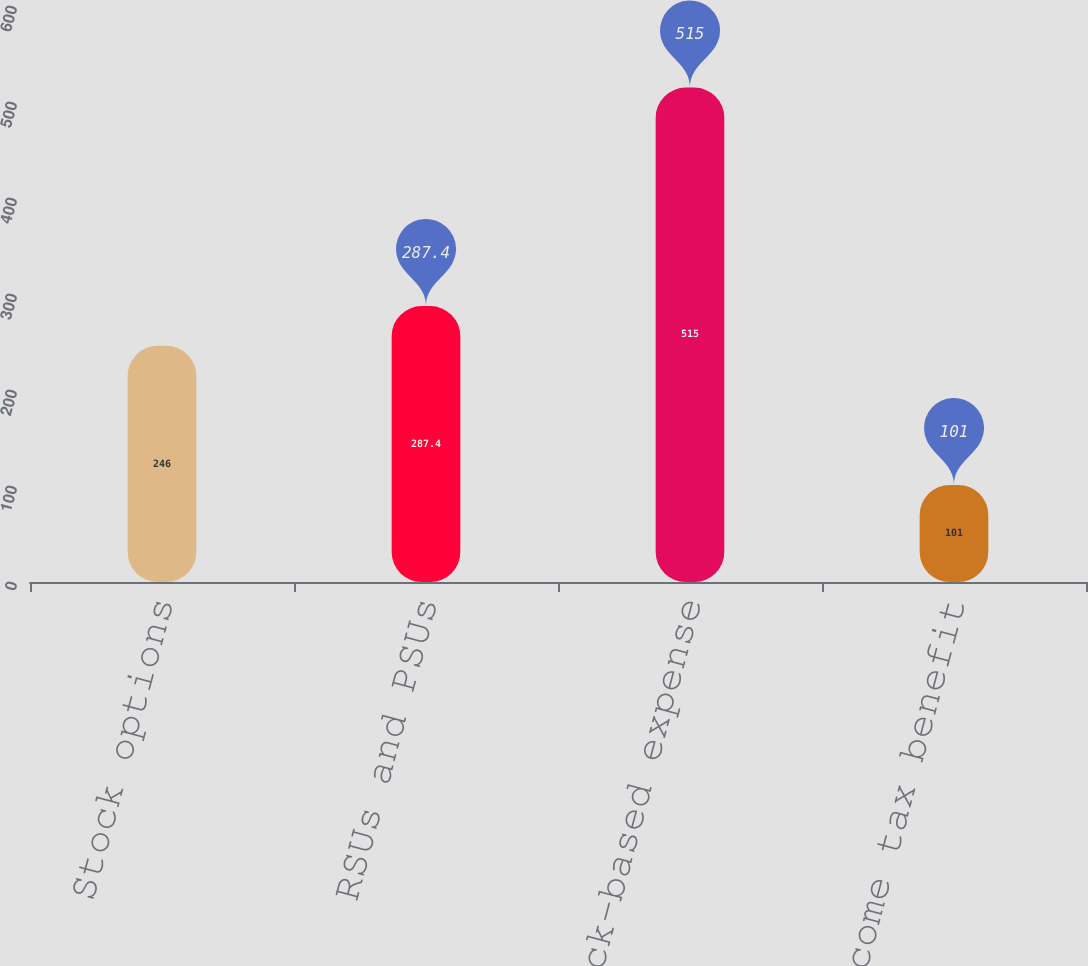Convert chart to OTSL. <chart><loc_0><loc_0><loc_500><loc_500><bar_chart><fcel>Stock options<fcel>RSUs and PSUs<fcel>Total stock-based expense<fcel>Income tax benefit<nl><fcel>246<fcel>287.4<fcel>515<fcel>101<nl></chart> 